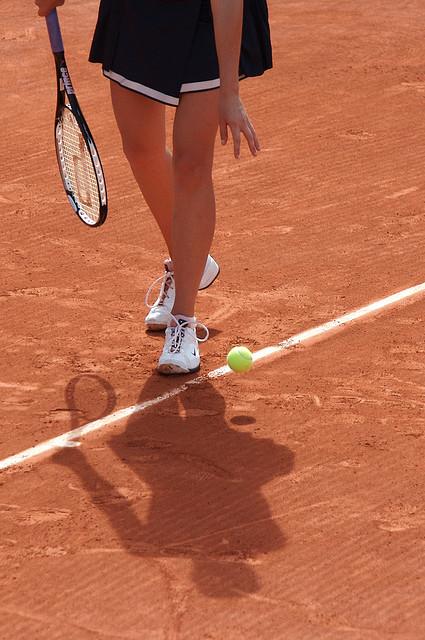What color is the girl's ball?
Give a very brief answer. Green. What letter is on the tennis racket?
Quick response, please. P. How many shadows are present?
Keep it brief. 1. 